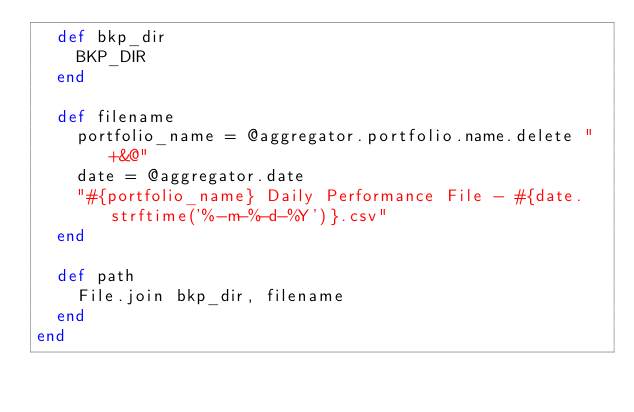<code> <loc_0><loc_0><loc_500><loc_500><_Ruby_>  def bkp_dir
    BKP_DIR
  end
  
  def filename
    portfolio_name = @aggregator.portfolio.name.delete "+&@"
    date = @aggregator.date
    "#{portfolio_name} Daily Performance File - #{date.strftime('%-m-%-d-%Y')}.csv"
  end
  
  def path
    File.join bkp_dir, filename
  end
end
</code> 